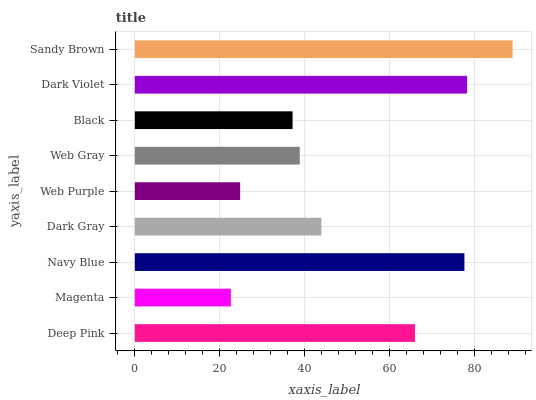Is Magenta the minimum?
Answer yes or no. Yes. Is Sandy Brown the maximum?
Answer yes or no. Yes. Is Navy Blue the minimum?
Answer yes or no. No. Is Navy Blue the maximum?
Answer yes or no. No. Is Navy Blue greater than Magenta?
Answer yes or no. Yes. Is Magenta less than Navy Blue?
Answer yes or no. Yes. Is Magenta greater than Navy Blue?
Answer yes or no. No. Is Navy Blue less than Magenta?
Answer yes or no. No. Is Dark Gray the high median?
Answer yes or no. Yes. Is Dark Gray the low median?
Answer yes or no. Yes. Is Web Gray the high median?
Answer yes or no. No. Is Sandy Brown the low median?
Answer yes or no. No. 